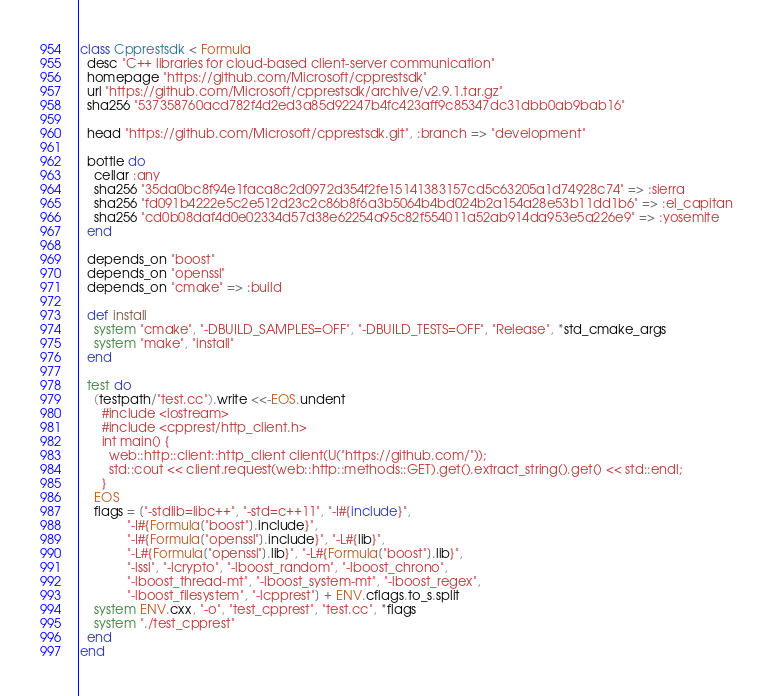<code> <loc_0><loc_0><loc_500><loc_500><_Ruby_>class Cpprestsdk < Formula
  desc "C++ libraries for cloud-based client-server communication"
  homepage "https://github.com/Microsoft/cpprestsdk"
  url "https://github.com/Microsoft/cpprestsdk/archive/v2.9.1.tar.gz"
  sha256 "537358760acd782f4d2ed3a85d92247b4fc423aff9c85347dc31dbb0ab9bab16"

  head "https://github.com/Microsoft/cpprestsdk.git", :branch => "development"

  bottle do
    cellar :any
    sha256 "35da0bc8f94e1faca8c2d0972d354f2fe15141383157cd5c63205a1d74928c74" => :sierra
    sha256 "fd091b4222e5c2e512d23c2c86b8f6a3b5064b4bd024b2a154a28e53b11dd1b6" => :el_capitan
    sha256 "cd0b08daf4d0e02334d57d38e62254a95c82f554011a52ab914da953e5a226e9" => :yosemite
  end

  depends_on "boost"
  depends_on "openssl"
  depends_on "cmake" => :build

  def install
    system "cmake", "-DBUILD_SAMPLES=OFF", "-DBUILD_TESTS=OFF", "Release", *std_cmake_args
    system "make", "install"
  end

  test do
    (testpath/"test.cc").write <<-EOS.undent
      #include <iostream>
      #include <cpprest/http_client.h>
      int main() {
        web::http::client::http_client client(U("https://github.com/"));
        std::cout << client.request(web::http::methods::GET).get().extract_string().get() << std::endl;
      }
    EOS
    flags = ["-stdlib=libc++", "-std=c++11", "-I#{include}",
             "-I#{Formula["boost"].include}",
             "-I#{Formula["openssl"].include}", "-L#{lib}",
             "-L#{Formula["openssl"].lib}", "-L#{Formula["boost"].lib}",
             "-lssl", "-lcrypto", "-lboost_random", "-lboost_chrono",
             "-lboost_thread-mt", "-lboost_system-mt", "-lboost_regex",
             "-lboost_filesystem", "-lcpprest"] + ENV.cflags.to_s.split
    system ENV.cxx, "-o", "test_cpprest", "test.cc", *flags
    system "./test_cpprest"
  end
end
</code> 